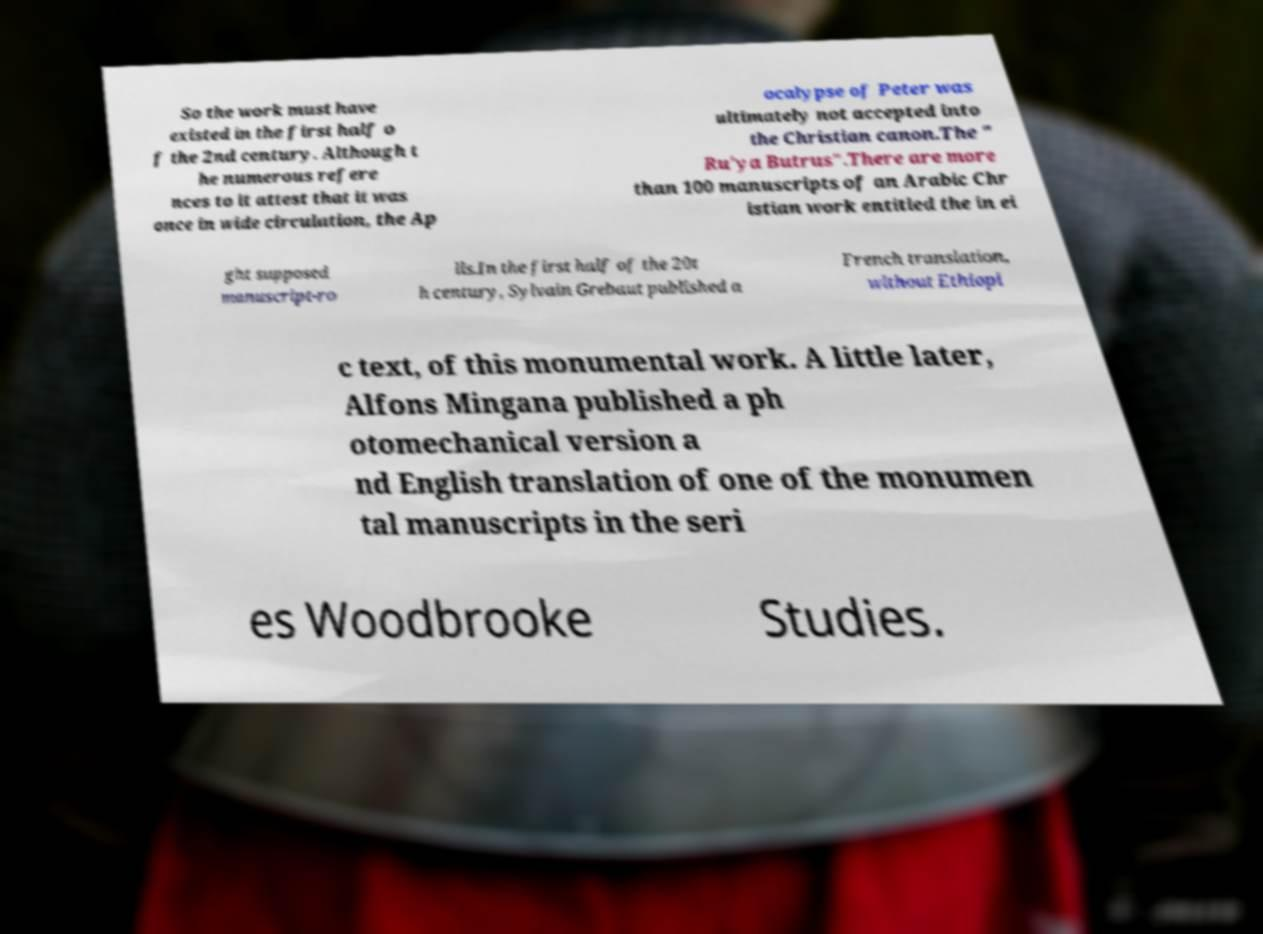Could you extract and type out the text from this image? So the work must have existed in the first half o f the 2nd century. Although t he numerous refere nces to it attest that it was once in wide circulation, the Ap ocalypse of Peter was ultimately not accepted into the Christian canon.The " Ru'ya Butrus".There are more than 100 manuscripts of an Arabic Chr istian work entitled the in ei ght supposed manuscript-ro lls.In the first half of the 20t h century, Sylvain Grebaut published a French translation, without Ethiopi c text, of this monumental work. A little later, Alfons Mingana published a ph otomechanical version a nd English translation of one of the monumen tal manuscripts in the seri es Woodbrooke Studies. 